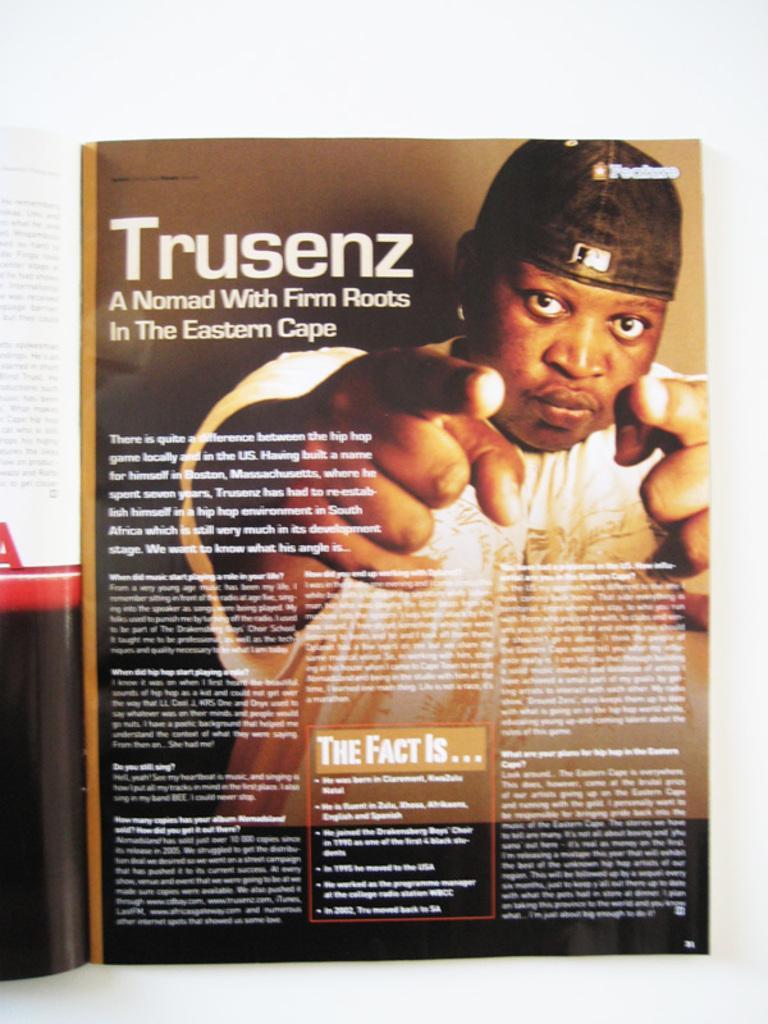Describe this image in one or two sentences. In this image, we can see a page on the white background contains a person and some text. 